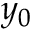Convert formula to latex. <formula><loc_0><loc_0><loc_500><loc_500>y _ { 0 }</formula> 